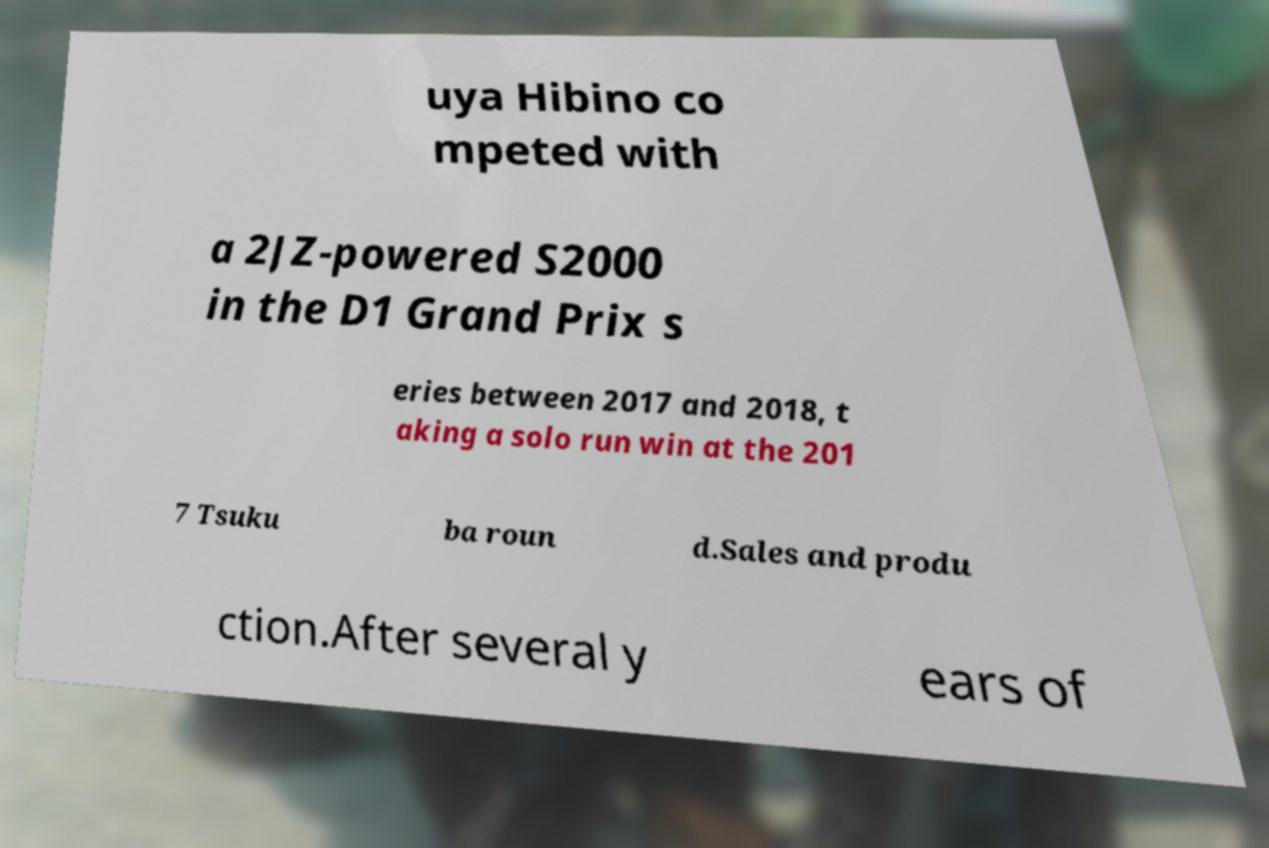For documentation purposes, I need the text within this image transcribed. Could you provide that? uya Hibino co mpeted with a 2JZ-powered S2000 in the D1 Grand Prix s eries between 2017 and 2018, t aking a solo run win at the 201 7 Tsuku ba roun d.Sales and produ ction.After several y ears of 